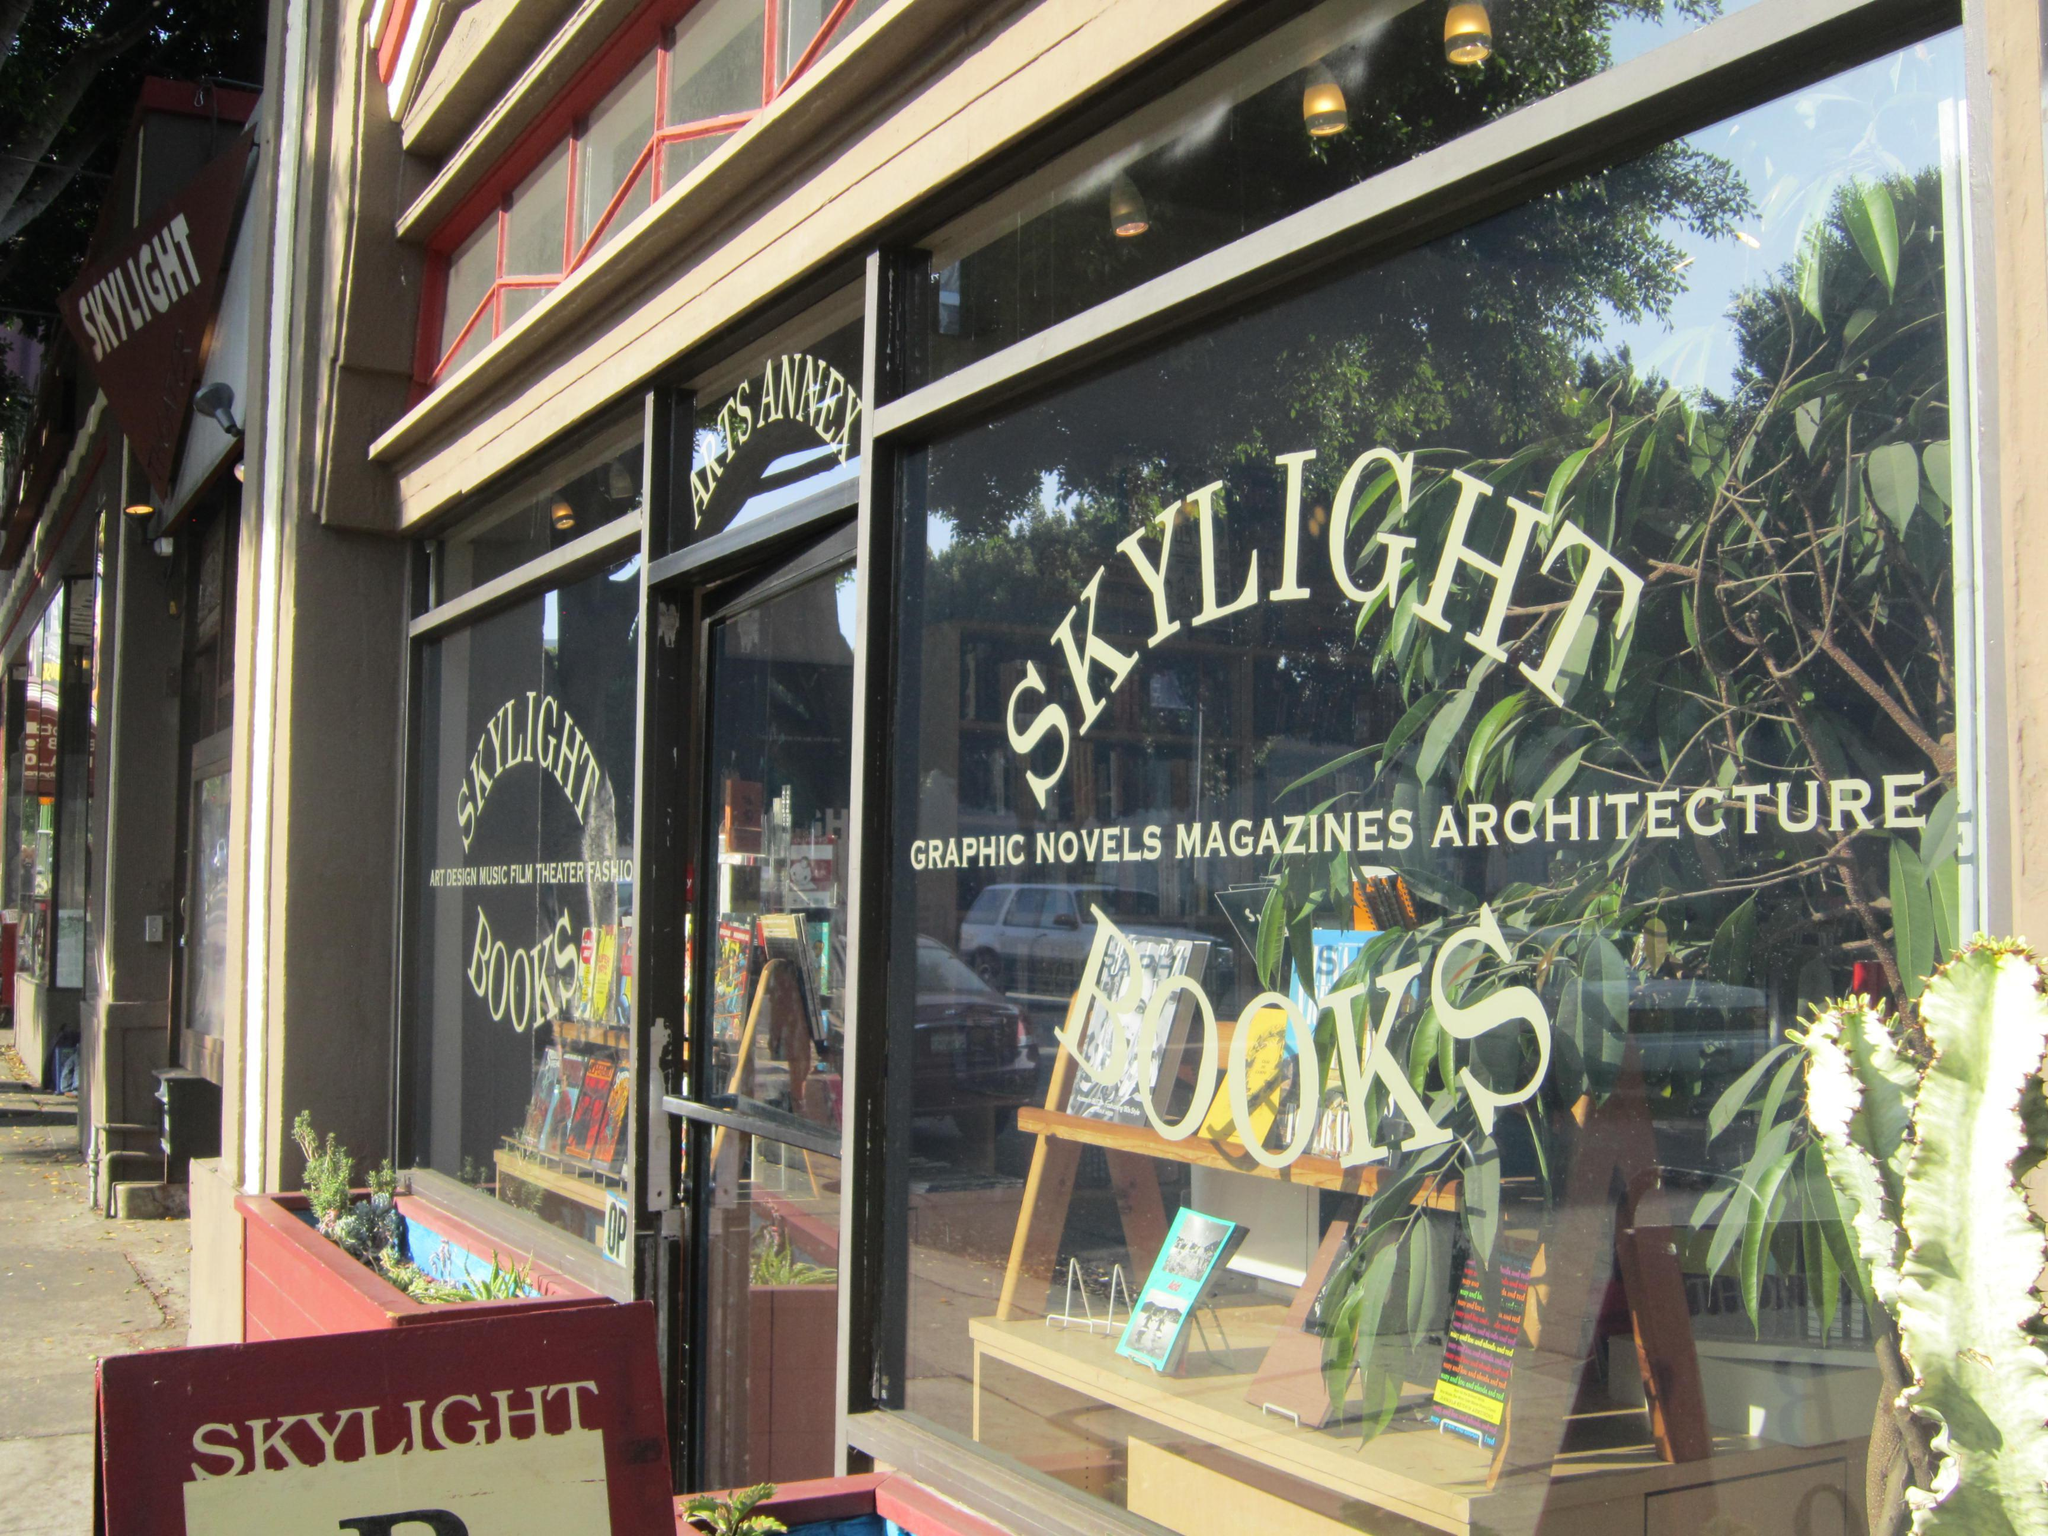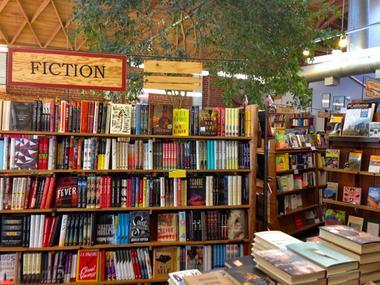The first image is the image on the left, the second image is the image on the right. Examine the images to the left and right. Is the description "In the bookstore there is a single green plant hanging from the brown triangle roof pattern." accurate? Answer yes or no. Yes. The first image is the image on the left, the second image is the image on the right. Considering the images on both sides, is "Green foliage is hanging over bookshelves in a shop with diamond shapes in light wood on the upper part." valid? Answer yes or no. Yes. 